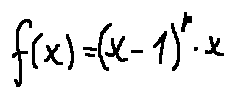<formula> <loc_0><loc_0><loc_500><loc_500>f ( x ) = ( x - 1 ) ^ { p } \cdot x</formula> 